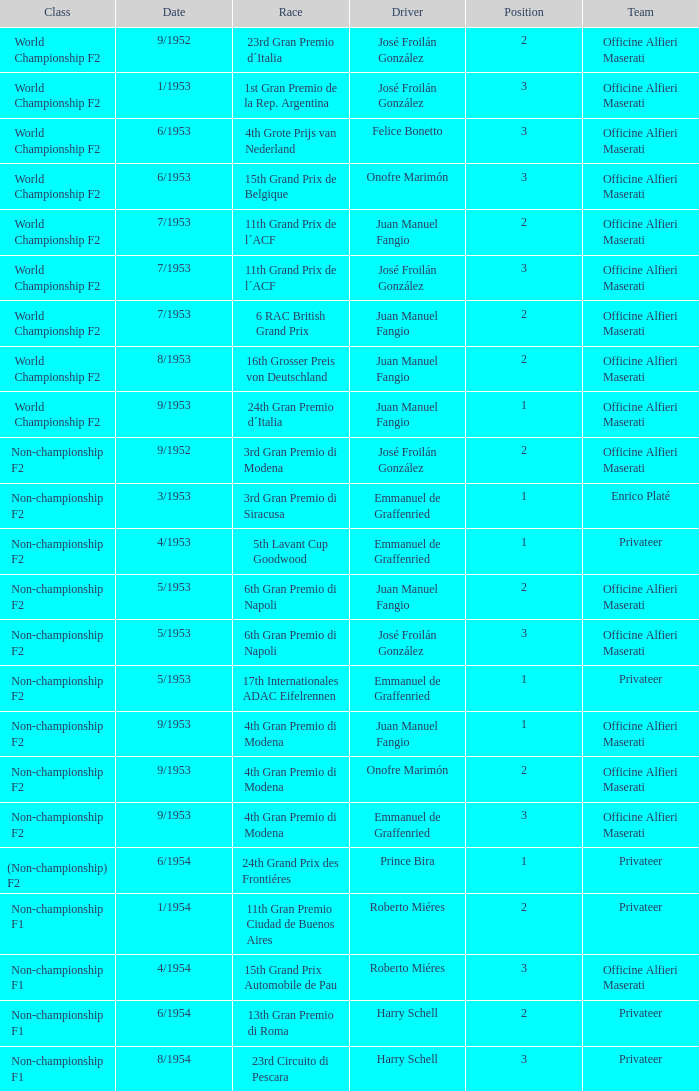What class has the date of 8/1954? Non-championship F1. Parse the full table. {'header': ['Class', 'Date', 'Race', 'Driver', 'Position', 'Team'], 'rows': [['World Championship F2', '9/1952', '23rd Gran Premio d´Italia', 'José Froilán González', '2', 'Officine Alfieri Maserati'], ['World Championship F2', '1/1953', '1st Gran Premio de la Rep. Argentina', 'José Froilán González', '3', 'Officine Alfieri Maserati'], ['World Championship F2', '6/1953', '4th Grote Prijs van Nederland', 'Felice Bonetto', '3', 'Officine Alfieri Maserati'], ['World Championship F2', '6/1953', '15th Grand Prix de Belgique', 'Onofre Marimón', '3', 'Officine Alfieri Maserati'], ['World Championship F2', '7/1953', '11th Grand Prix de l´ACF', 'Juan Manuel Fangio', '2', 'Officine Alfieri Maserati'], ['World Championship F2', '7/1953', '11th Grand Prix de l´ACF', 'José Froilán González', '3', 'Officine Alfieri Maserati'], ['World Championship F2', '7/1953', '6 RAC British Grand Prix', 'Juan Manuel Fangio', '2', 'Officine Alfieri Maserati'], ['World Championship F2', '8/1953', '16th Grosser Preis von Deutschland', 'Juan Manuel Fangio', '2', 'Officine Alfieri Maserati'], ['World Championship F2', '9/1953', '24th Gran Premio d´Italia', 'Juan Manuel Fangio', '1', 'Officine Alfieri Maserati'], ['Non-championship F2', '9/1952', '3rd Gran Premio di Modena', 'José Froilán González', '2', 'Officine Alfieri Maserati'], ['Non-championship F2', '3/1953', '3rd Gran Premio di Siracusa', 'Emmanuel de Graffenried', '1', 'Enrico Platé'], ['Non-championship F2', '4/1953', '5th Lavant Cup Goodwood', 'Emmanuel de Graffenried', '1', 'Privateer'], ['Non-championship F2', '5/1953', '6th Gran Premio di Napoli', 'Juan Manuel Fangio', '2', 'Officine Alfieri Maserati'], ['Non-championship F2', '5/1953', '6th Gran Premio di Napoli', 'José Froilán González', '3', 'Officine Alfieri Maserati'], ['Non-championship F2', '5/1953', '17th Internationales ADAC Eifelrennen', 'Emmanuel de Graffenried', '1', 'Privateer'], ['Non-championship F2', '9/1953', '4th Gran Premio di Modena', 'Juan Manuel Fangio', '1', 'Officine Alfieri Maserati'], ['Non-championship F2', '9/1953', '4th Gran Premio di Modena', 'Onofre Marimón', '2', 'Officine Alfieri Maserati'], ['Non-championship F2', '9/1953', '4th Gran Premio di Modena', 'Emmanuel de Graffenried', '3', 'Officine Alfieri Maserati'], ['(Non-championship) F2', '6/1954', '24th Grand Prix des Frontiéres', 'Prince Bira', '1', 'Privateer'], ['Non-championship F1', '1/1954', '11th Gran Premio Ciudad de Buenos Aires', 'Roberto Miéres', '2', 'Privateer'], ['Non-championship F1', '4/1954', '15th Grand Prix Automobile de Pau', 'Roberto Miéres', '3', 'Officine Alfieri Maserati'], ['Non-championship F1', '6/1954', '13th Gran Premio di Roma', 'Harry Schell', '2', 'Privateer'], ['Non-championship F1', '8/1954', '23rd Circuito di Pescara', 'Harry Schell', '3', 'Privateer']]} 